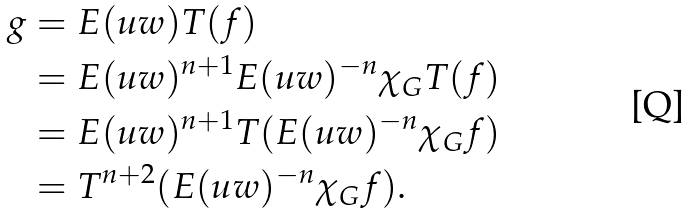<formula> <loc_0><loc_0><loc_500><loc_500>g & = E ( u w ) T ( f ) \\ & = E ( u w ) ^ { n + 1 } E ( u w ) ^ { - n } \chi _ { G } T ( f ) \\ & = E ( u w ) ^ { n + 1 } T ( E ( u w ) ^ { - n } \chi _ { G } f ) \\ & = T ^ { n + 2 } ( E ( u w ) ^ { - n } \chi _ { G } f ) .</formula> 